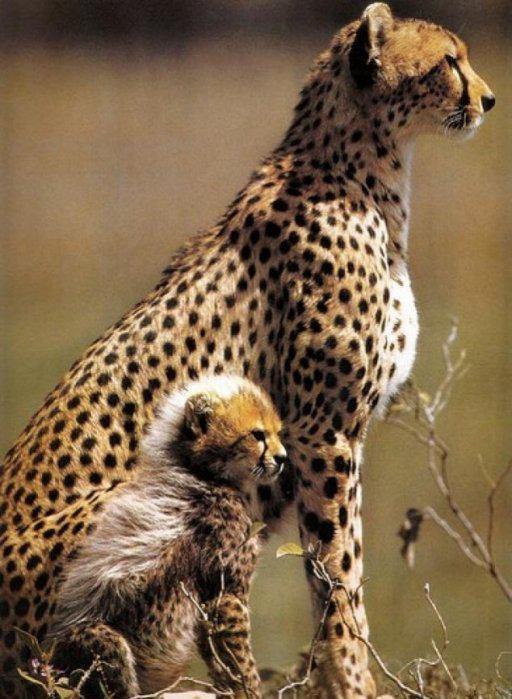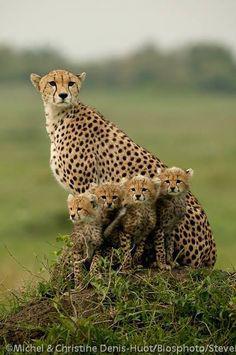The first image is the image on the left, the second image is the image on the right. Examine the images to the left and right. Is the description "One image features exactly one young cheetah next to an adult cheetah sitting upright with its head and body facing right." accurate? Answer yes or no. Yes. The first image is the image on the left, the second image is the image on the right. Examine the images to the left and right. Is the description "At least one baby cheetah is looking straight into the camera." accurate? Answer yes or no. Yes. 